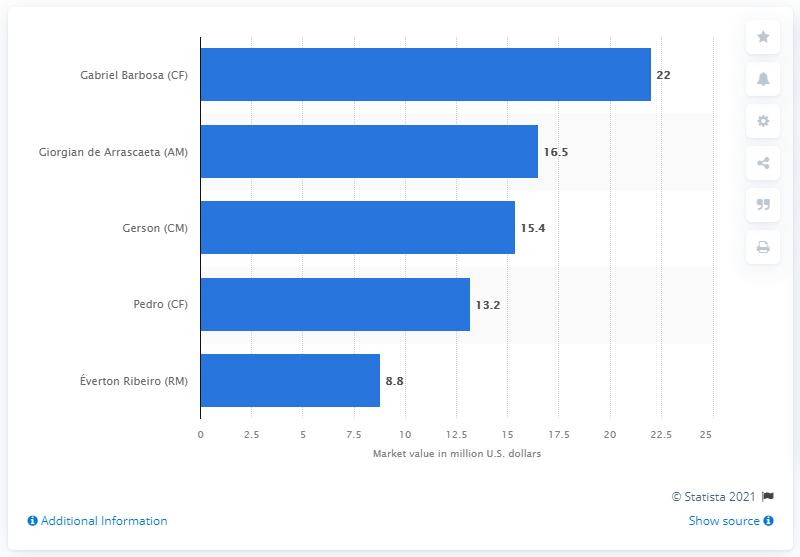Specify some key components in this picture. The market value of Gabriel Barbosa was 22 million dollars. 